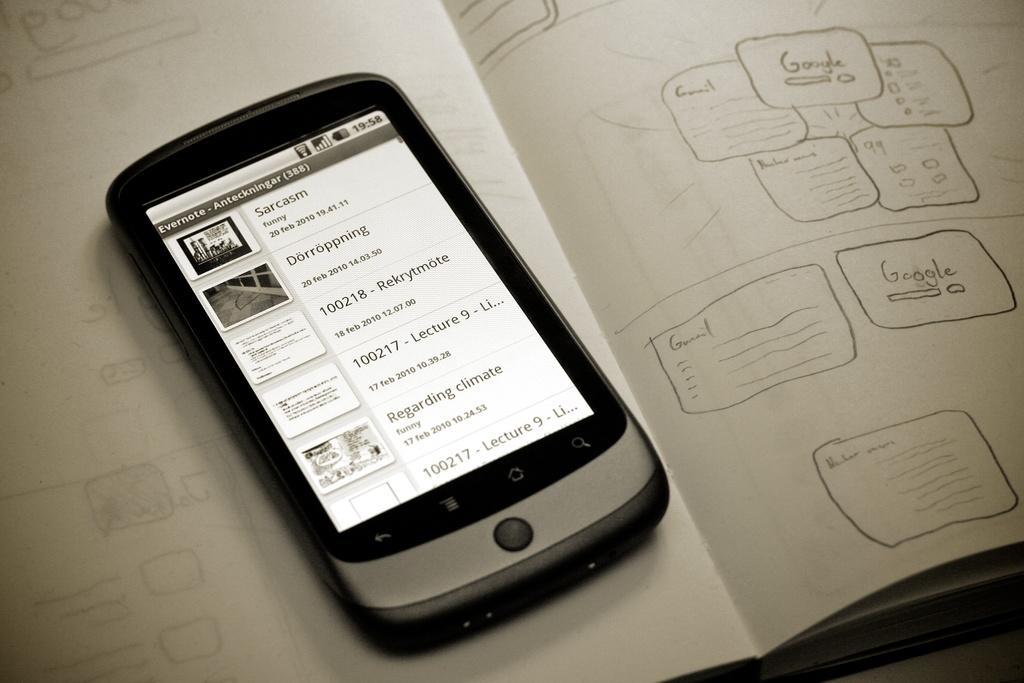<image>
Give a short and clear explanation of the subsequent image. A phone showing a list in Evernote sitting on a notebook with a written web map. 